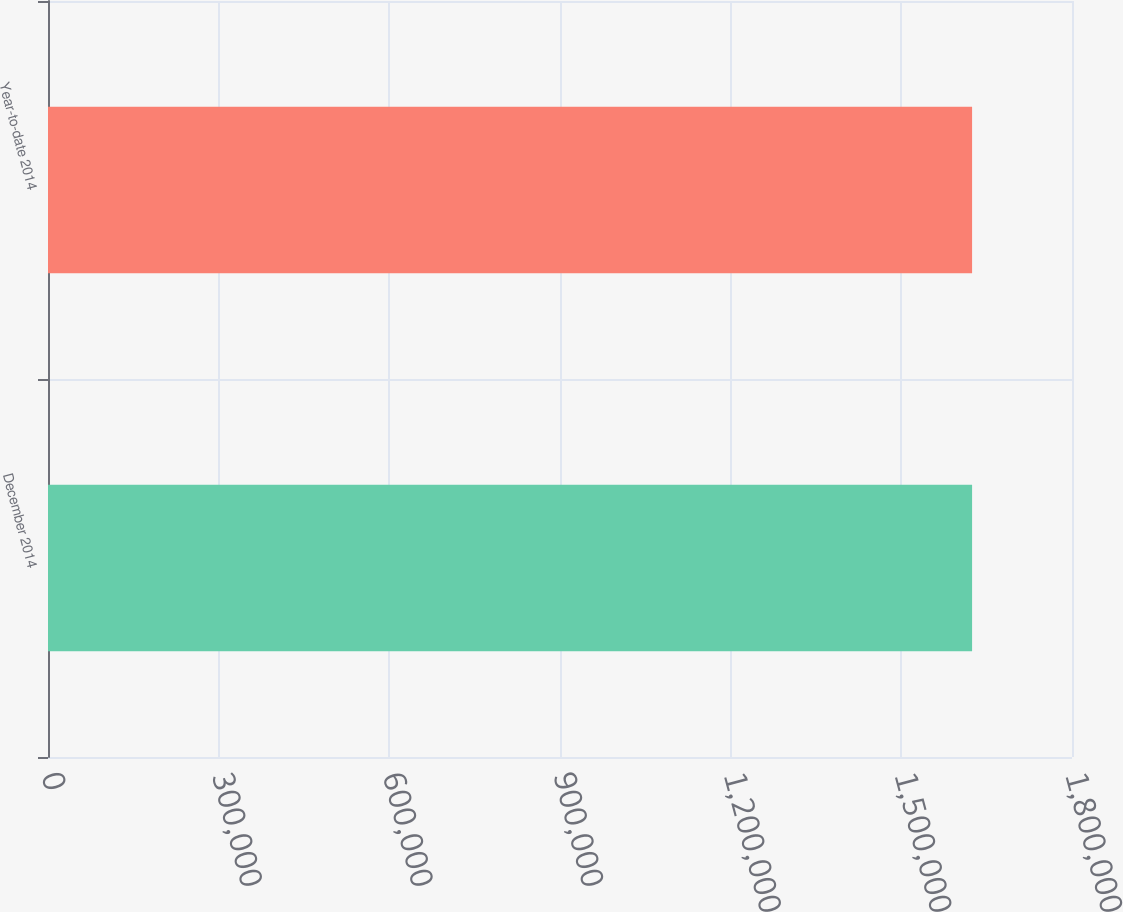<chart> <loc_0><loc_0><loc_500><loc_500><bar_chart><fcel>December 2014<fcel>Year-to-date 2014<nl><fcel>1.62436e+06<fcel>1.62436e+06<nl></chart> 